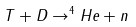<formula> <loc_0><loc_0><loc_500><loc_500>T + D \rightarrow ^ { 4 } H e + n</formula> 